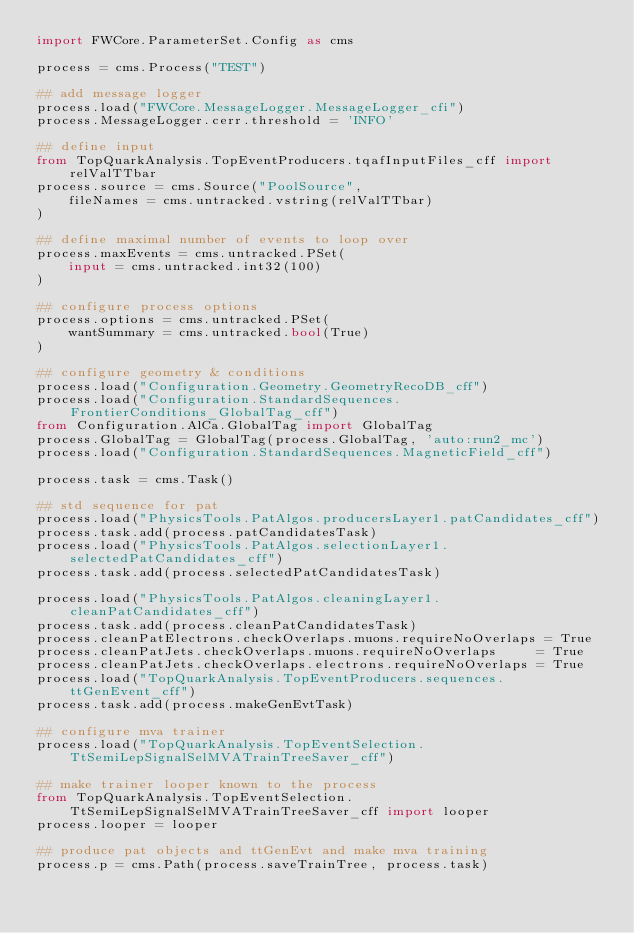Convert code to text. <code><loc_0><loc_0><loc_500><loc_500><_Python_>import FWCore.ParameterSet.Config as cms

process = cms.Process("TEST")

## add message logger
process.load("FWCore.MessageLogger.MessageLogger_cfi")
process.MessageLogger.cerr.threshold = 'INFO'

## define input
from TopQuarkAnalysis.TopEventProducers.tqafInputFiles_cff import relValTTbar
process.source = cms.Source("PoolSource",
    fileNames = cms.untracked.vstring(relValTTbar)
)

## define maximal number of events to loop over
process.maxEvents = cms.untracked.PSet(
    input = cms.untracked.int32(100)
)

## configure process options
process.options = cms.untracked.PSet(
    wantSummary = cms.untracked.bool(True)
)

## configure geometry & conditions
process.load("Configuration.Geometry.GeometryRecoDB_cff")
process.load("Configuration.StandardSequences.FrontierConditions_GlobalTag_cff")
from Configuration.AlCa.GlobalTag import GlobalTag
process.GlobalTag = GlobalTag(process.GlobalTag, 'auto:run2_mc')
process.load("Configuration.StandardSequences.MagneticField_cff")

process.task = cms.Task()

## std sequence for pat
process.load("PhysicsTools.PatAlgos.producersLayer1.patCandidates_cff")
process.task.add(process.patCandidatesTask)
process.load("PhysicsTools.PatAlgos.selectionLayer1.selectedPatCandidates_cff")
process.task.add(process.selectedPatCandidatesTask)

process.load("PhysicsTools.PatAlgos.cleaningLayer1.cleanPatCandidates_cff")
process.task.add(process.cleanPatCandidatesTask)
process.cleanPatElectrons.checkOverlaps.muons.requireNoOverlaps = True
process.cleanPatJets.checkOverlaps.muons.requireNoOverlaps     = True
process.cleanPatJets.checkOverlaps.electrons.requireNoOverlaps = True
process.load("TopQuarkAnalysis.TopEventProducers.sequences.ttGenEvent_cff")
process.task.add(process.makeGenEvtTask)

## configure mva trainer
process.load("TopQuarkAnalysis.TopEventSelection.TtSemiLepSignalSelMVATrainTreeSaver_cff")

## make trainer looper known to the process
from TopQuarkAnalysis.TopEventSelection.TtSemiLepSignalSelMVATrainTreeSaver_cff import looper
process.looper = looper

## produce pat objects and ttGenEvt and make mva training
process.p = cms.Path(process.saveTrainTree, process.task)
</code> 